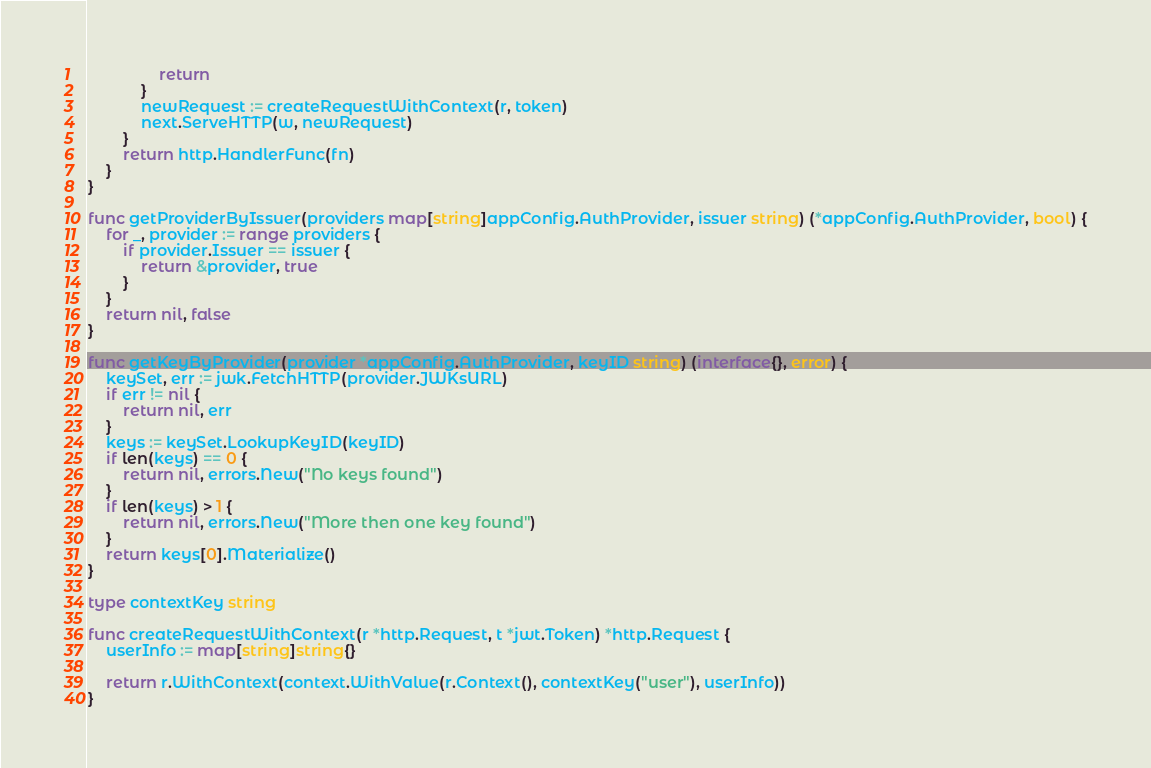Convert code to text. <code><loc_0><loc_0><loc_500><loc_500><_Go_>				return
			}
			newRequest := createRequestWithContext(r, token)
			next.ServeHTTP(w, newRequest)
		}
		return http.HandlerFunc(fn)
	}
}

func getProviderByIssuer(providers map[string]appConfig.AuthProvider, issuer string) (*appConfig.AuthProvider, bool) {
	for _, provider := range providers {
		if provider.Issuer == issuer {
			return &provider, true
		}
	}
	return nil, false
}

func getKeyByProvider(provider *appConfig.AuthProvider, keyID string) (interface{}, error) {
	keySet, err := jwk.FetchHTTP(provider.JWKsURL)
	if err != nil {
		return nil, err
	}
	keys := keySet.LookupKeyID(keyID)
	if len(keys) == 0 {
		return nil, errors.New("No keys found")
	}
	if len(keys) > 1 {
		return nil, errors.New("More then one key found")
	}
	return keys[0].Materialize()
}

type contextKey string

func createRequestWithContext(r *http.Request, t *jwt.Token) *http.Request {
	userInfo := map[string]string{}

	return r.WithContext(context.WithValue(r.Context(), contextKey("user"), userInfo))
}
</code> 